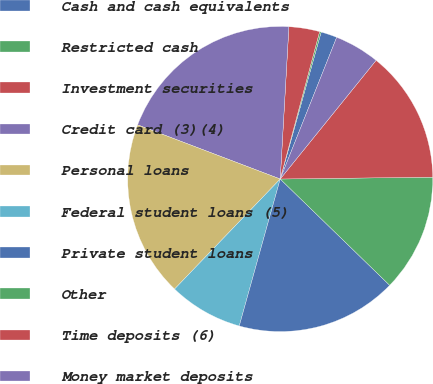Convert chart to OTSL. <chart><loc_0><loc_0><loc_500><loc_500><pie_chart><fcel>Cash and cash equivalents<fcel>Restricted cash<fcel>Investment securities<fcel>Credit card (3)(4)<fcel>Personal loans<fcel>Federal student loans (5)<fcel>Private student loans<fcel>Other<fcel>Time deposits (6)<fcel>Money market deposits<nl><fcel>1.71%<fcel>0.17%<fcel>3.25%<fcel>20.13%<fcel>18.6%<fcel>7.85%<fcel>17.06%<fcel>12.46%<fcel>13.99%<fcel>4.78%<nl></chart> 